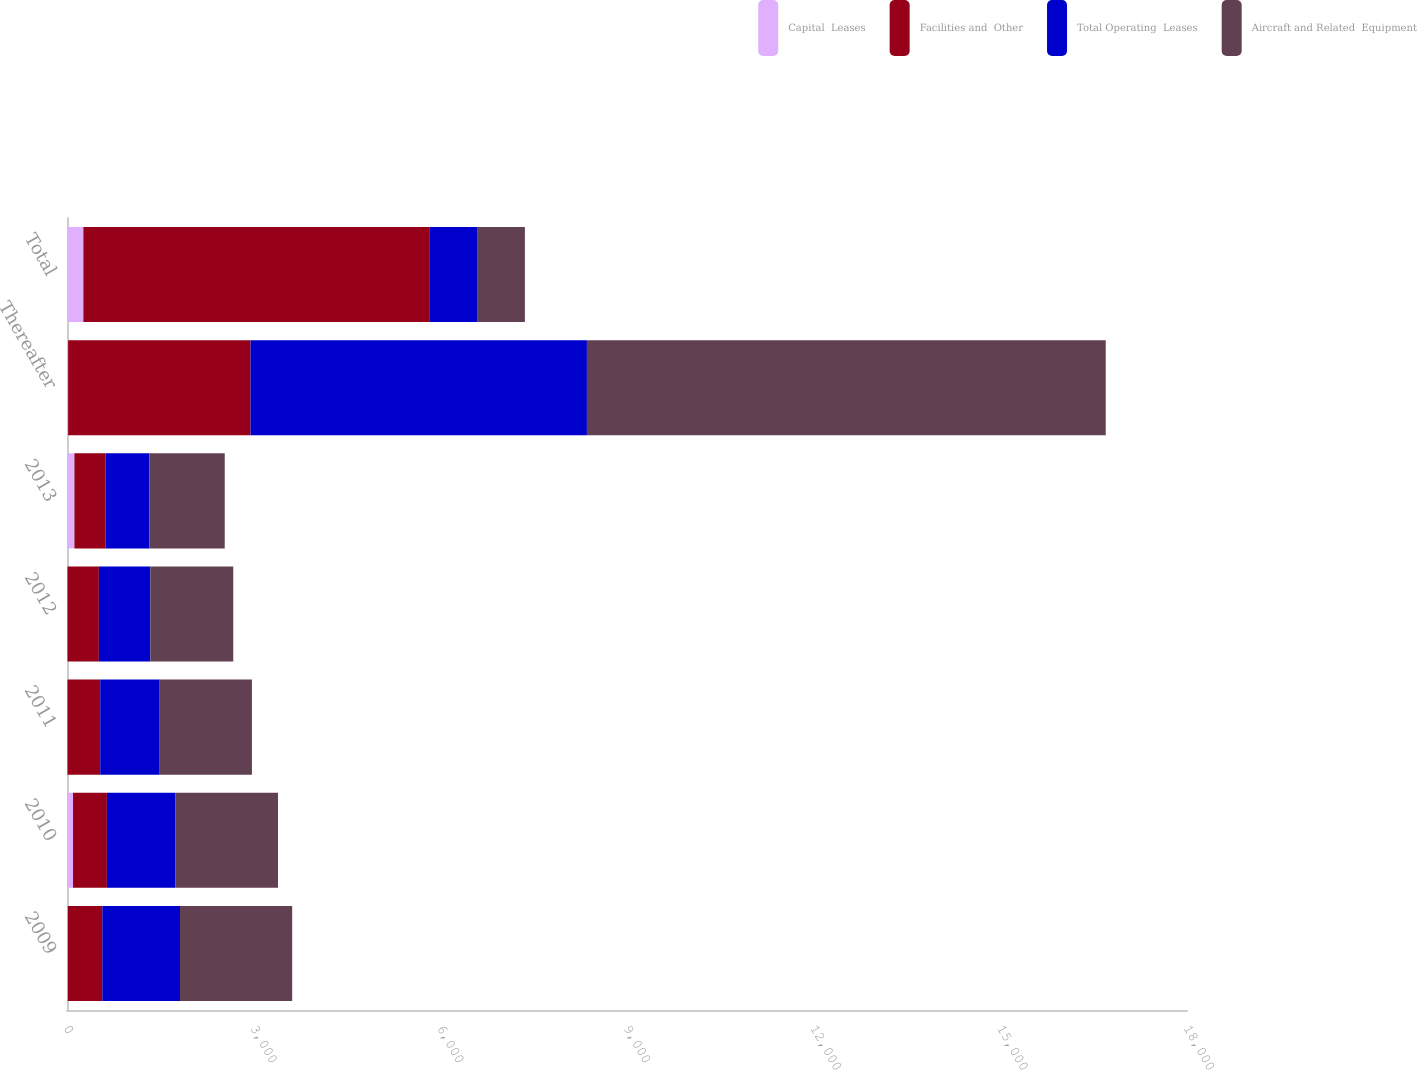<chart> <loc_0><loc_0><loc_500><loc_500><stacked_bar_chart><ecel><fcel>2009<fcel>2010<fcel>2011<fcel>2012<fcel>2013<fcel>Thereafter<fcel>Total<nl><fcel>Capital  Leases<fcel>13<fcel>97<fcel>8<fcel>8<fcel>119<fcel>18<fcel>263<nl><fcel>Facilities and  Other<fcel>555<fcel>544<fcel>526<fcel>504<fcel>499<fcel>2931<fcel>5559<nl><fcel>Total Operating  Leases<fcel>1248<fcel>1103<fcel>956<fcel>828<fcel>709<fcel>5407<fcel>768.5<nl><fcel>Aircraft and Related  Equipment<fcel>1803<fcel>1647<fcel>1482<fcel>1332<fcel>1208<fcel>8338<fcel>768.5<nl></chart> 